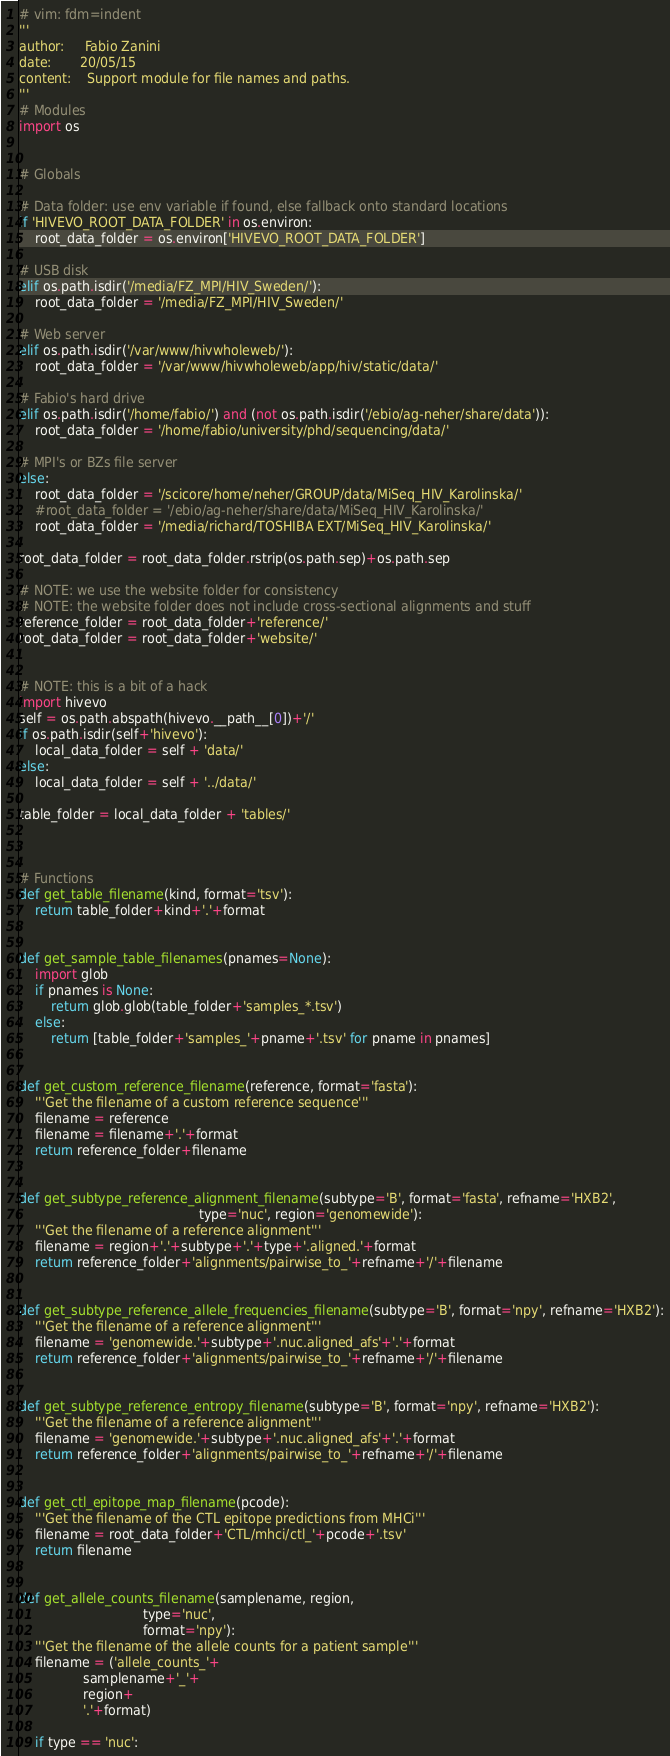Convert code to text. <code><loc_0><loc_0><loc_500><loc_500><_Python_># vim: fdm=indent
'''
author:     Fabio Zanini
date:       20/05/15
content:    Support module for file names and paths.
'''
# Modules
import os


# Globals

# Data folder: use env variable if found, else fallback onto standard locations
if 'HIVEVO_ROOT_DATA_FOLDER' in os.environ:
    root_data_folder = os.environ['HIVEVO_ROOT_DATA_FOLDER']

# USB disk
elif os.path.isdir('/media/FZ_MPI/HIV_Sweden/'):
    root_data_folder = '/media/FZ_MPI/HIV_Sweden/'

# Web server
elif os.path.isdir('/var/www/hivwholeweb/'):
    root_data_folder = '/var/www/hivwholeweb/app/hiv/static/data/'

# Fabio's hard drive
elif os.path.isdir('/home/fabio/') and (not os.path.isdir('/ebio/ag-neher/share/data')):
    root_data_folder = '/home/fabio/university/phd/sequencing/data/'

# MPI's or BZs file server
else:
    root_data_folder = '/scicore/home/neher/GROUP/data/MiSeq_HIV_Karolinska/'
    #root_data_folder = '/ebio/ag-neher/share/data/MiSeq_HIV_Karolinska/'
    root_data_folder = '/media/richard/TOSHIBA EXT/MiSeq_HIV_Karolinska/'

root_data_folder = root_data_folder.rstrip(os.path.sep)+os.path.sep

# NOTE: we use the website folder for consistency
# NOTE: the website folder does not include cross-sectional alignments and stuff
reference_folder = root_data_folder+'reference/'
root_data_folder = root_data_folder+'website/'


# NOTE: this is a bit of a hack
import hivevo
self = os.path.abspath(hivevo.__path__[0])+'/'
if os.path.isdir(self+'hivevo'):
    local_data_folder = self + 'data/'
else:
    local_data_folder = self + '../data/'

table_folder = local_data_folder + 'tables/'



# Functions
def get_table_filename(kind, format='tsv'):
    return table_folder+kind+'.'+format


def get_sample_table_filenames(pnames=None):
    import glob
    if pnames is None:
        return glob.glob(table_folder+'samples_*.tsv')
    else:
        return [table_folder+'samples_'+pname+'.tsv' for pname in pnames]


def get_custom_reference_filename(reference, format='fasta'):
    '''Get the filename of a custom reference sequence'''
    filename = reference
    filename = filename+'.'+format
    return reference_folder+filename


def get_subtype_reference_alignment_filename(subtype='B', format='fasta', refname='HXB2',
                                             type='nuc', region='genomewide'):
    '''Get the filename of a reference alignment'''
    filename = region+'.'+subtype+'.'+type+'.aligned.'+format
    return reference_folder+'alignments/pairwise_to_'+refname+'/'+filename


def get_subtype_reference_allele_frequencies_filename(subtype='B', format='npy', refname='HXB2'):
    '''Get the filename of a reference alignment'''
    filename = 'genomewide.'+subtype+'.nuc.aligned_afs'+'.'+format
    return reference_folder+'alignments/pairwise_to_'+refname+'/'+filename


def get_subtype_reference_entropy_filename(subtype='B', format='npy', refname='HXB2'):
    '''Get the filename of a reference alignment'''
    filename = 'genomewide.'+subtype+'.nuc.aligned_afs'+'.'+format
    return reference_folder+'alignments/pairwise_to_'+refname+'/'+filename


def get_ctl_epitope_map_filename(pcode):
    '''Get the filename of the CTL epitope predictions from MHCi'''
    filename = root_data_folder+'CTL/mhci/ctl_'+pcode+'.tsv'
    return filename


def get_allele_counts_filename(samplename, region,
                               type='nuc',
                               format='npy'):
    '''Get the filename of the allele counts for a patient sample'''
    filename = ('allele_counts_'+
                samplename+'_'+
                region+
                '.'+format)

    if type == 'nuc':</code> 